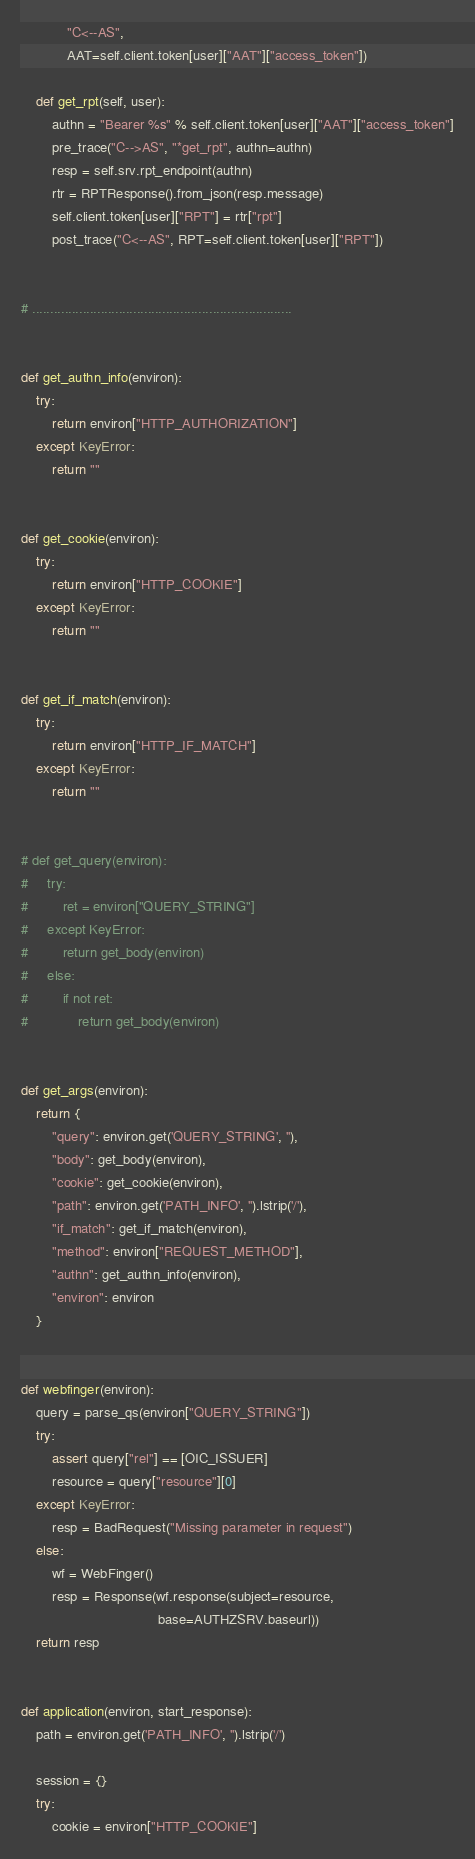<code> <loc_0><loc_0><loc_500><loc_500><_Python_>            "C<--AS",
            AAT=self.client.token[user]["AAT"]["access_token"])

    def get_rpt(self, user):
        authn = "Bearer %s" % self.client.token[user]["AAT"]["access_token"]
        pre_trace("C-->AS", "*get_rpt", authn=authn)
        resp = self.srv.rpt_endpoint(authn)
        rtr = RPTResponse().from_json(resp.message)
        self.client.token[user]["RPT"] = rtr["rpt"]
        post_trace("C<--AS", RPT=self.client.token[user]["RPT"])


# ........................................................................


def get_authn_info(environ):
    try:
        return environ["HTTP_AUTHORIZATION"]
    except KeyError:
        return ""


def get_cookie(environ):
    try:
        return environ["HTTP_COOKIE"]
    except KeyError:
        return ""


def get_if_match(environ):
    try:
        return environ["HTTP_IF_MATCH"]
    except KeyError:
        return ""


# def get_query(environ):
#     try:
#         ret = environ["QUERY_STRING"]
#     except KeyError:
#         return get_body(environ)
#     else:
#         if not ret:
#             return get_body(environ)


def get_args(environ):
    return {
        "query": environ.get('QUERY_STRING', ''),
        "body": get_body(environ),
        "cookie": get_cookie(environ),
        "path": environ.get('PATH_INFO', '').lstrip('/'),
        "if_match": get_if_match(environ),
        "method": environ["REQUEST_METHOD"],
        "authn": get_authn_info(environ),
        "environ": environ
    }


def webfinger(environ):
    query = parse_qs(environ["QUERY_STRING"])
    try:
        assert query["rel"] == [OIC_ISSUER]
        resource = query["resource"][0]
    except KeyError:
        resp = BadRequest("Missing parameter in request")
    else:
        wf = WebFinger()
        resp = Response(wf.response(subject=resource,
                                    base=AUTHZSRV.baseurl))
    return resp


def application(environ, start_response):
    path = environ.get('PATH_INFO', '').lstrip('/')

    session = {}
    try:
        cookie = environ["HTTP_COOKIE"]</code> 